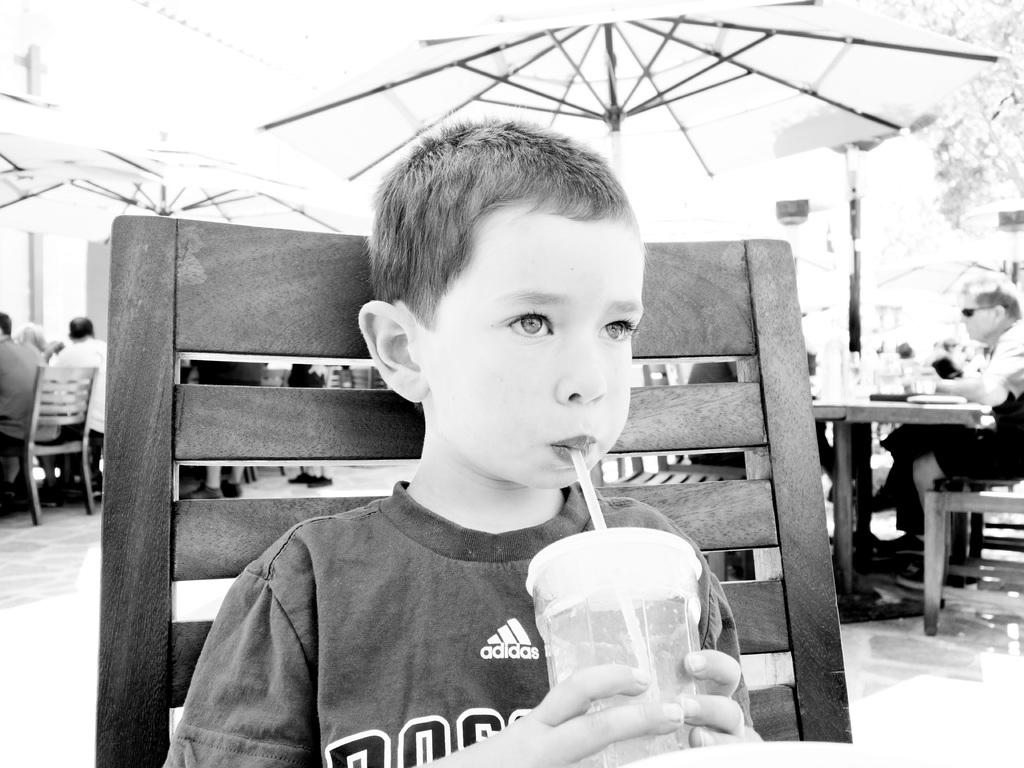Who is the main subject in the image? There is a boy in the image. What is the boy doing in the image? The boy is sitting on a chair and drinking a cool drink. Can you describe the people in the background of the image? How many quinces are being held by the woman in the image? 